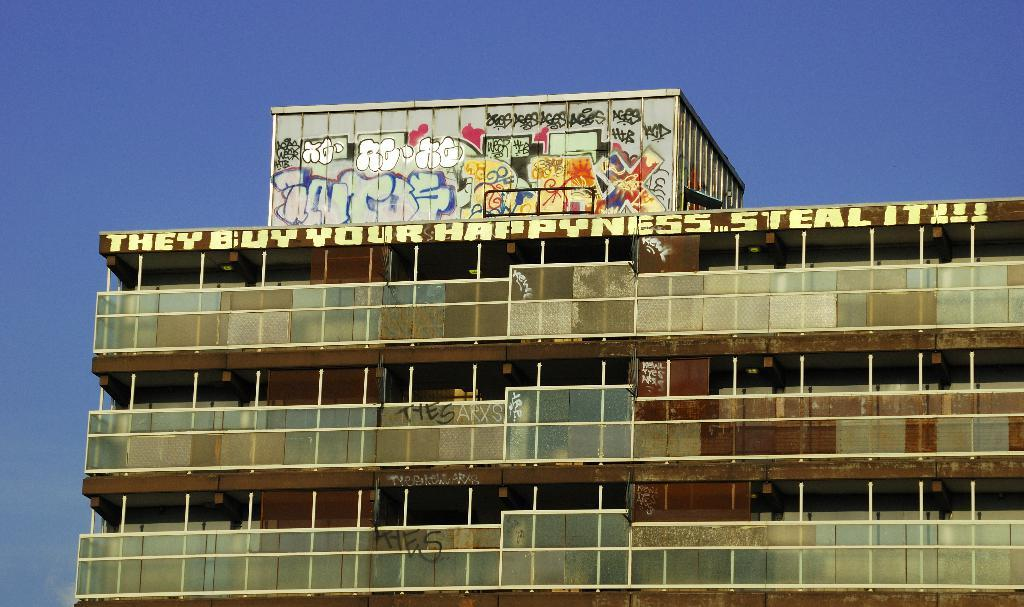What is the main subject in the center of the image? There is a building in the center of the image. What can be seen at the top of the image? The sky is visible at the top of the image. What level of difficulty is the building designed for in the image? The image does not provide information about the building's difficulty level, so it cannot be determined. 